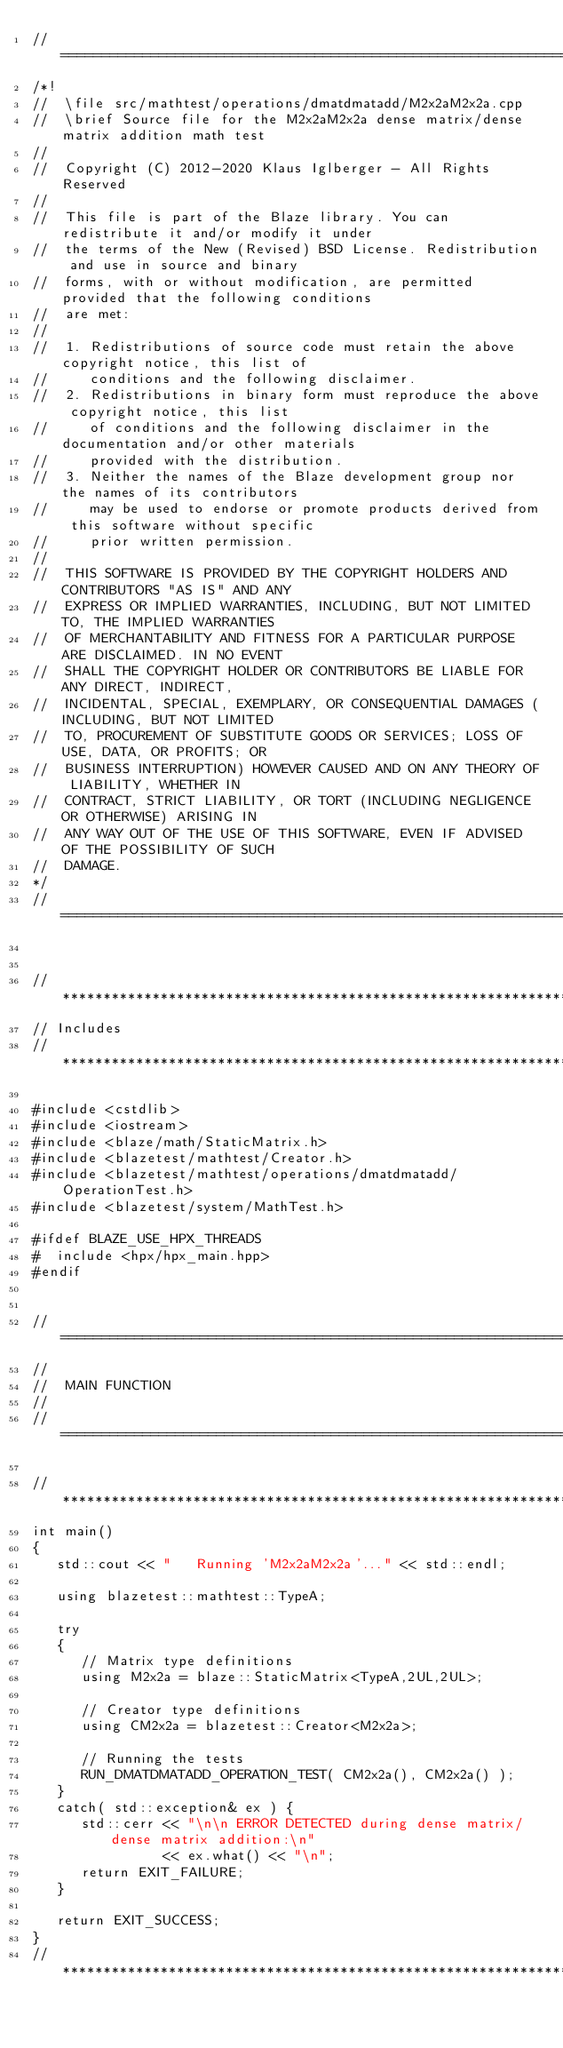Convert code to text. <code><loc_0><loc_0><loc_500><loc_500><_C++_>//=================================================================================================
/*!
//  \file src/mathtest/operations/dmatdmatadd/M2x2aM2x2a.cpp
//  \brief Source file for the M2x2aM2x2a dense matrix/dense matrix addition math test
//
//  Copyright (C) 2012-2020 Klaus Iglberger - All Rights Reserved
//
//  This file is part of the Blaze library. You can redistribute it and/or modify it under
//  the terms of the New (Revised) BSD License. Redistribution and use in source and binary
//  forms, with or without modification, are permitted provided that the following conditions
//  are met:
//
//  1. Redistributions of source code must retain the above copyright notice, this list of
//     conditions and the following disclaimer.
//  2. Redistributions in binary form must reproduce the above copyright notice, this list
//     of conditions and the following disclaimer in the documentation and/or other materials
//     provided with the distribution.
//  3. Neither the names of the Blaze development group nor the names of its contributors
//     may be used to endorse or promote products derived from this software without specific
//     prior written permission.
//
//  THIS SOFTWARE IS PROVIDED BY THE COPYRIGHT HOLDERS AND CONTRIBUTORS "AS IS" AND ANY
//  EXPRESS OR IMPLIED WARRANTIES, INCLUDING, BUT NOT LIMITED TO, THE IMPLIED WARRANTIES
//  OF MERCHANTABILITY AND FITNESS FOR A PARTICULAR PURPOSE ARE DISCLAIMED. IN NO EVENT
//  SHALL THE COPYRIGHT HOLDER OR CONTRIBUTORS BE LIABLE FOR ANY DIRECT, INDIRECT,
//  INCIDENTAL, SPECIAL, EXEMPLARY, OR CONSEQUENTIAL DAMAGES (INCLUDING, BUT NOT LIMITED
//  TO, PROCUREMENT OF SUBSTITUTE GOODS OR SERVICES; LOSS OF USE, DATA, OR PROFITS; OR
//  BUSINESS INTERRUPTION) HOWEVER CAUSED AND ON ANY THEORY OF LIABILITY, WHETHER IN
//  CONTRACT, STRICT LIABILITY, OR TORT (INCLUDING NEGLIGENCE OR OTHERWISE) ARISING IN
//  ANY WAY OUT OF THE USE OF THIS SOFTWARE, EVEN IF ADVISED OF THE POSSIBILITY OF SUCH
//  DAMAGE.
*/
//=================================================================================================


//*************************************************************************************************
// Includes
//*************************************************************************************************

#include <cstdlib>
#include <iostream>
#include <blaze/math/StaticMatrix.h>
#include <blazetest/mathtest/Creator.h>
#include <blazetest/mathtest/operations/dmatdmatadd/OperationTest.h>
#include <blazetest/system/MathTest.h>

#ifdef BLAZE_USE_HPX_THREADS
#  include <hpx/hpx_main.hpp>
#endif


//=================================================================================================
//
//  MAIN FUNCTION
//
//=================================================================================================

//*************************************************************************************************
int main()
{
   std::cout << "   Running 'M2x2aM2x2a'..." << std::endl;

   using blazetest::mathtest::TypeA;

   try
   {
      // Matrix type definitions
      using M2x2a = blaze::StaticMatrix<TypeA,2UL,2UL>;

      // Creator type definitions
      using CM2x2a = blazetest::Creator<M2x2a>;

      // Running the tests
      RUN_DMATDMATADD_OPERATION_TEST( CM2x2a(), CM2x2a() );
   }
   catch( std::exception& ex ) {
      std::cerr << "\n\n ERROR DETECTED during dense matrix/dense matrix addition:\n"
                << ex.what() << "\n";
      return EXIT_FAILURE;
   }

   return EXIT_SUCCESS;
}
//*************************************************************************************************
</code> 